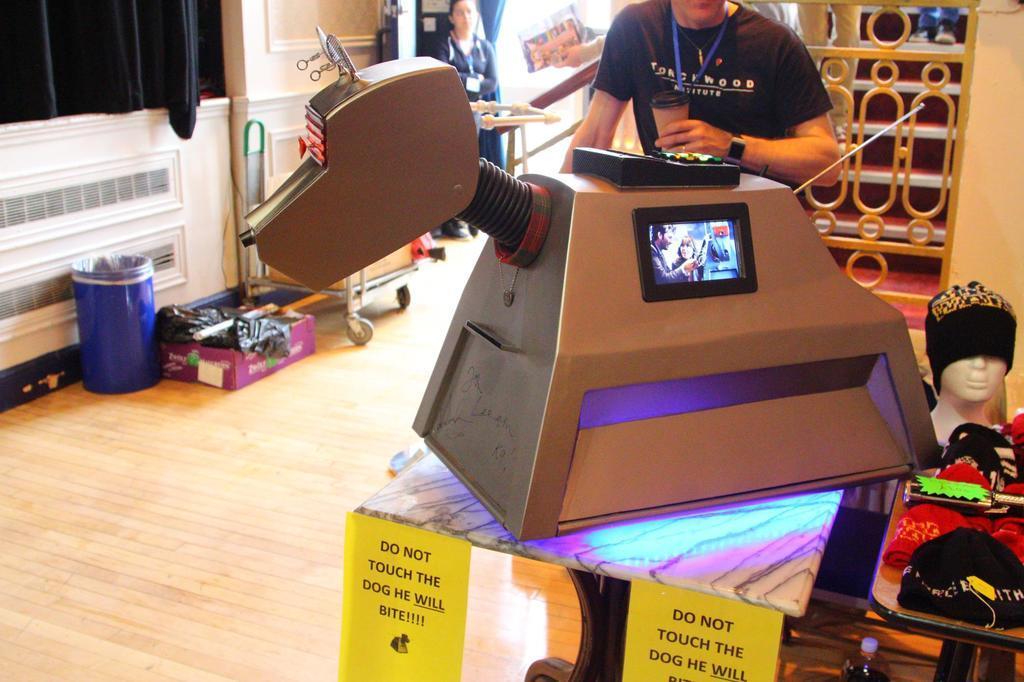Could you give a brief overview of what you see in this image? In this picture we can see a screen on a machine and the machine is on a table and to the table there are boards. On the rights doe of the machine, there is a mannequin head and some caps. Behind the man there are two people standing and a person is holding a cup. On the left side of the people there is a wall with a curtain and on the wooden floor there are some objects. 